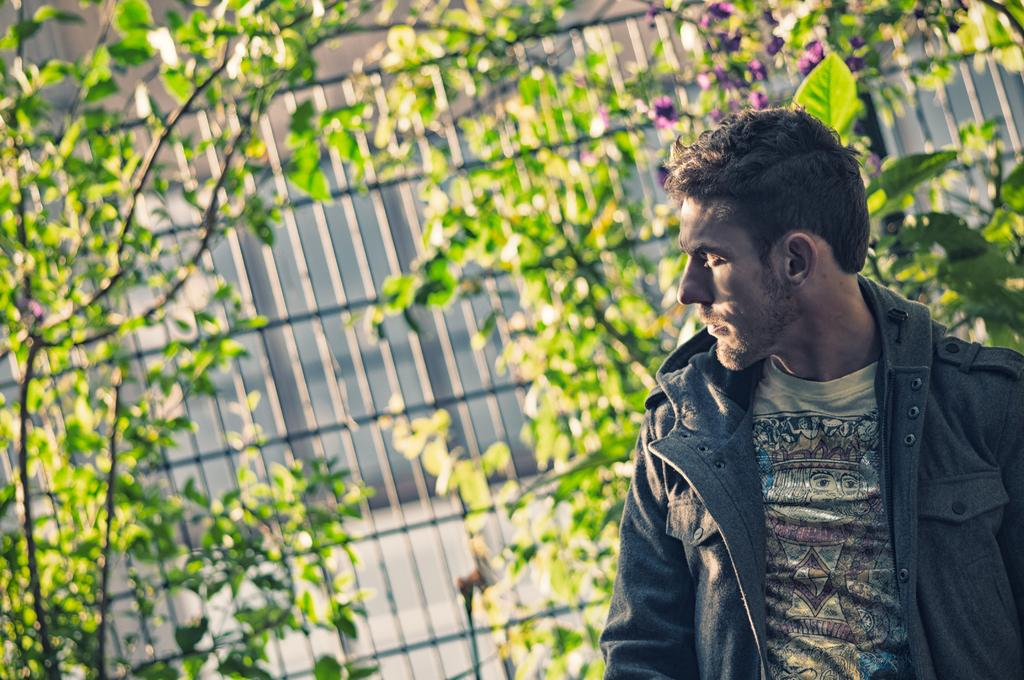Who is present in the image? There is a man in the image. Where is the man located in the image? The man is on the right side of the image. What is the man wearing? The man is wearing a t-shirt and a jacket. What can be seen in the background of the image? There are plants, an iron grill, and flowers in the background of the image. What type of island can be seen in the image? There is no island present in the image. 